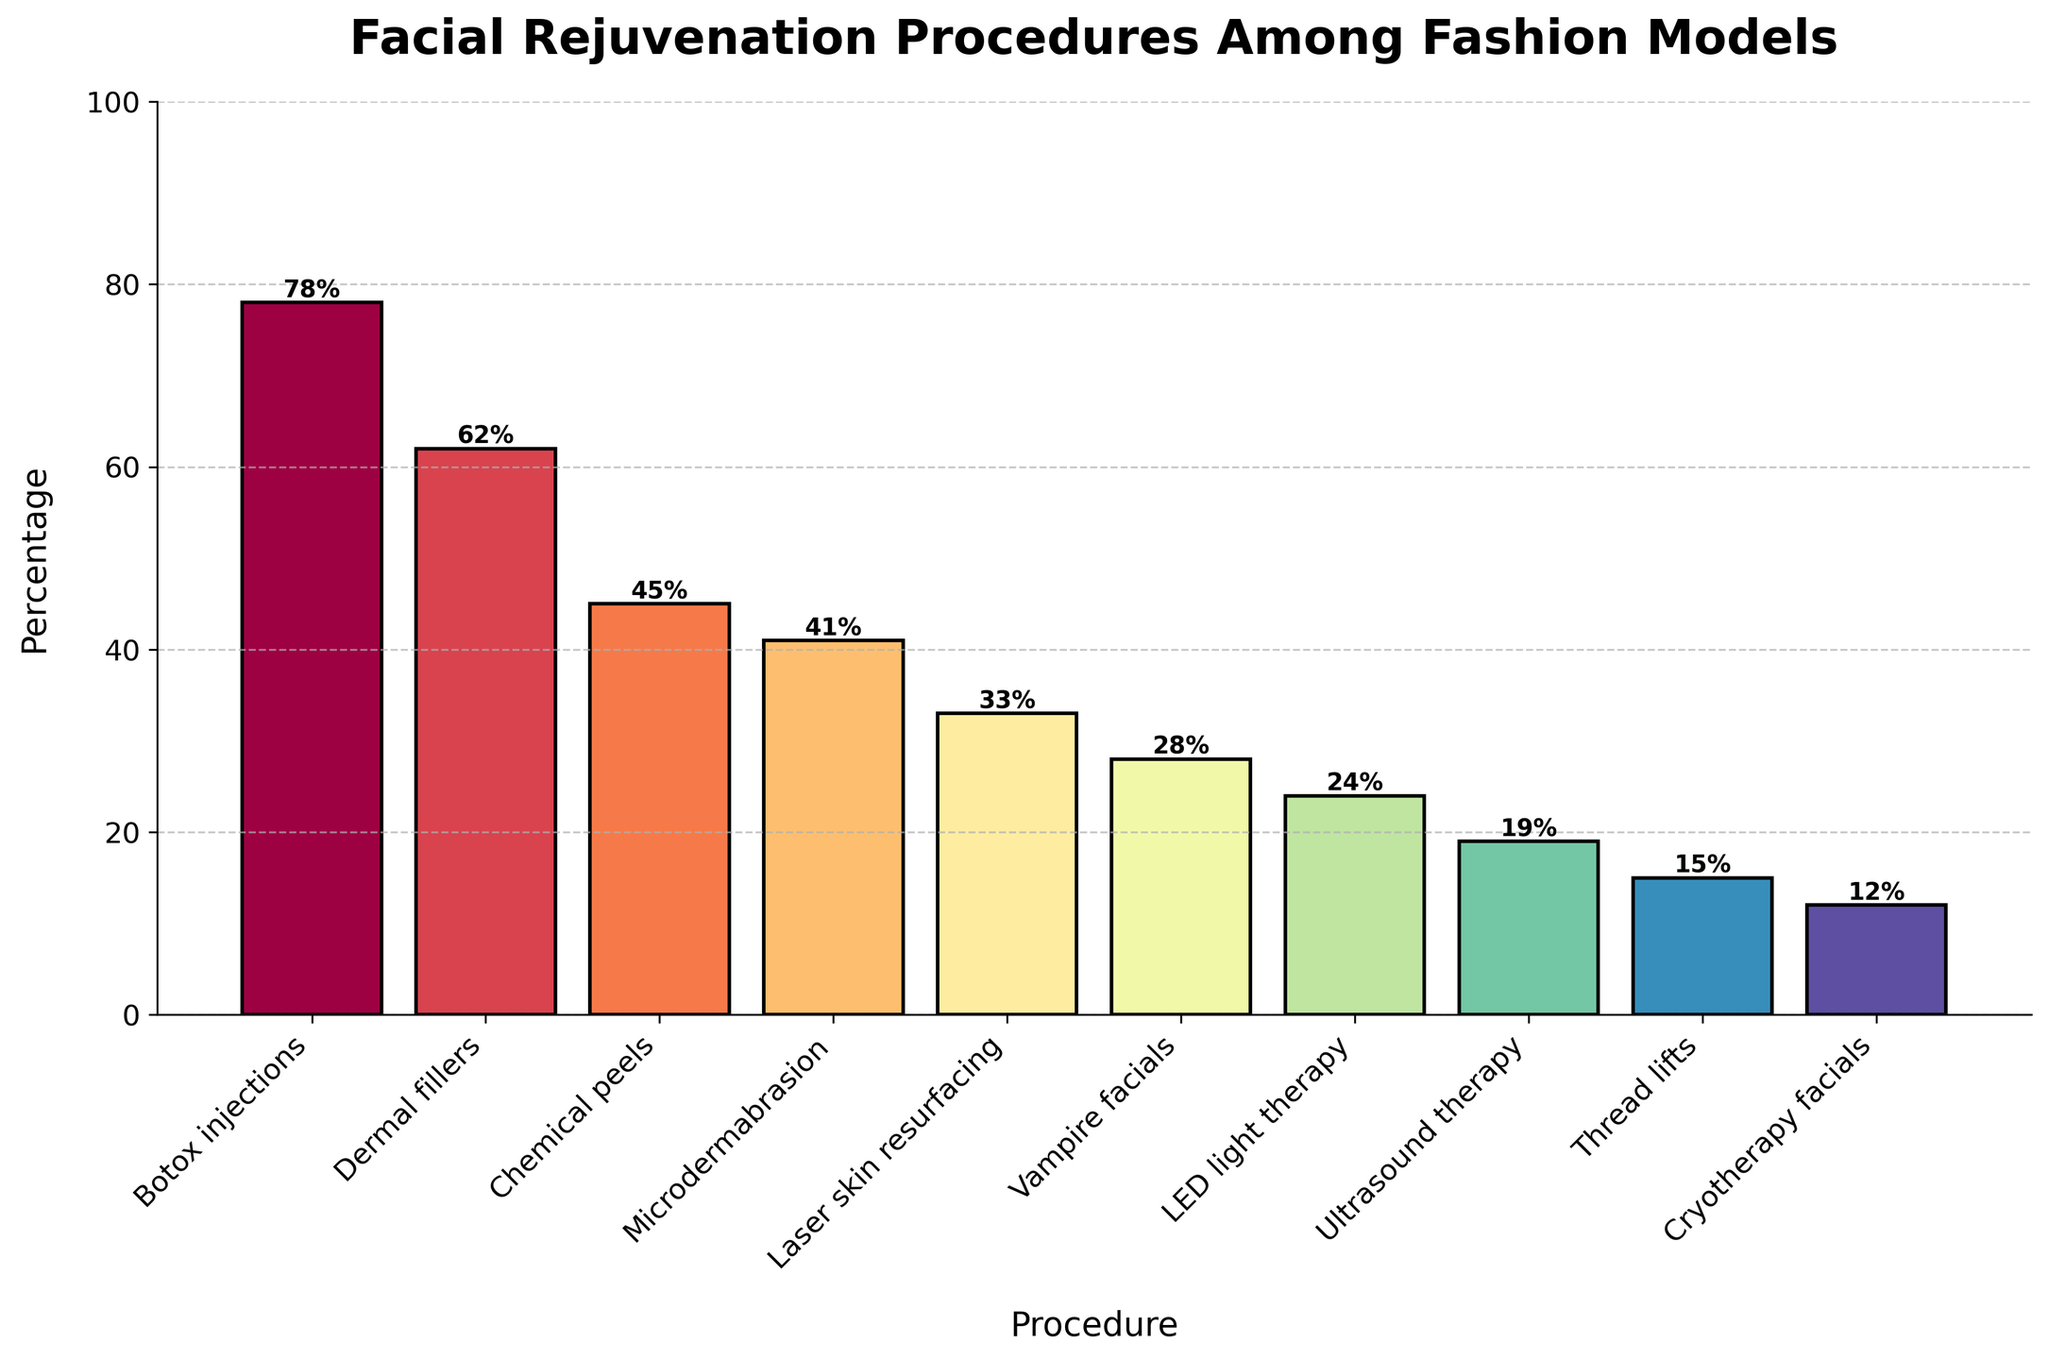What percentage of fashion models have undergone Botox injections? The percentage of fashion models who have undergone Botox injections is indicated at the top of the corresponding bar in the chart.
Answer: 78% Which facial rejuvenation procedure has the lowest percentage of fashion models? By looking at the height of the bars, Cryotherapy facials have the shortest bar, indicating the lowest percentage.
Answer: Cryotherapy facials Compare the percentages of models who have undergone Dermal fillers and Chemical peels. The percentage for Dermal fillers is 62%, and for Chemical peels it is 45%. Comparing these two values indicates that more models have undergone Dermal fillers.
Answer: Dermal fillers: 62%, Chemical peels: 45% What is the combined percentage for models who have had LED light therapy and Ultrasound therapy? Adding the percentages for LED light therapy (24%) and Ultrasound therapy (19%) gives: 24% + 19% = 43%.
Answer: 43% Is the percentage of models who have undergone Vampire facials greater than one-third of those who had Botox injections? One-third of Botox injections' 78% is 78/3 = 26%. Vampire facials stand at 28%, which is greater than 26%.
Answer: Yes What is the average percentage for models undergoing Microdermabrasion, Laser skin resurfacing, and Cryotherapy facials? The percentages are 41%, 33%, and 12%, respectively. Their sum is 41 + 33 + 12 = 86. Dividing by 3 gives 86/3 ≈ 28.67%.
Answer: 28.67% Which procedure has a percentage closest to 40%? Checking the percentages, Microdermabrasion is at 41%, which is nearest to 40%.
Answer: Microdermabrasion How much higher is the percentage for Thread lifts compared to Cryotherapy facials? The percentages are 15% for Thread lifts and 12% for Cryotherapy facials. The difference is 15% - 12% = 3%.
Answer: 3% What is the median percentage of all listed procedures? Listing percentages in ascending order: 12, 15, 19, 24, 28, 33, 41, 45, 62, 78. The median is the middle value of the ordered list, which is 28.
Answer: 28% How does the height of the bar for Laser skin resurfacing compare to that for Dermal fillers visually? The bar for Laser skin resurfacing is shorter than the bar for Dermal fillers, indicating a lower percentage.
Answer: Shorter 